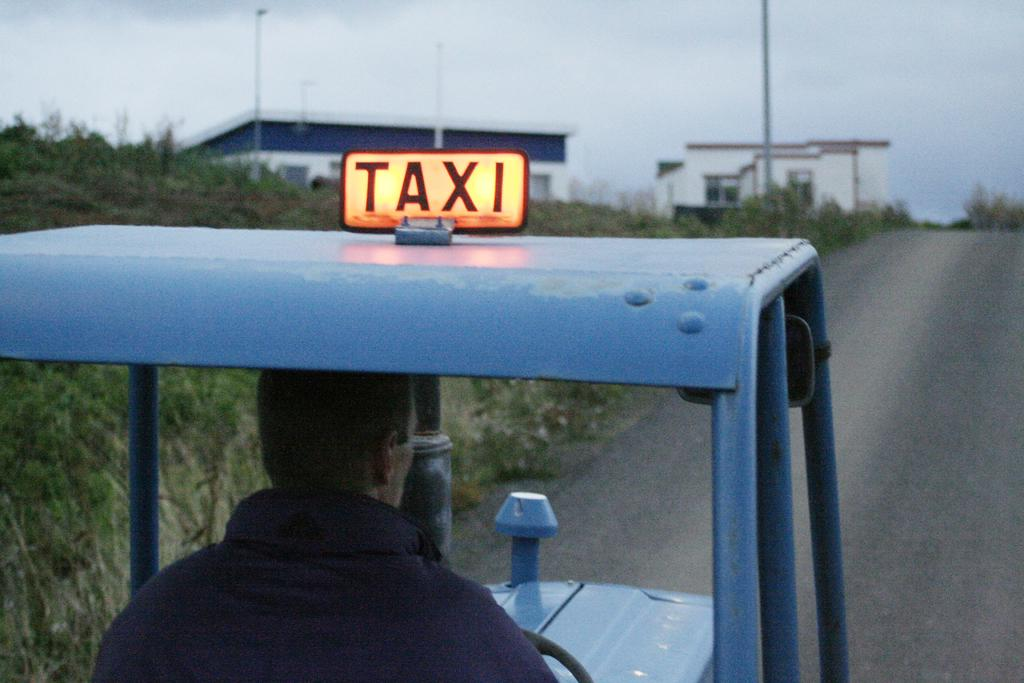What is the person in the image doing? There is a person riding a vehicle on the road. What can be seen on the ground in the background? There is grass on the ground in the background. What structures are visible in the background? There are poles and buildings in the background. What architectural feature can be seen in the buildings? There are windows visible in the background. What is visible in the sky in the background? There are clouds in the sky in the background. What type of knee injury can be seen in the image? There is no knee injury present in the image; it features a person riding a vehicle on the road. What type of glass object is visible in the image? There is no glass object present in the image. 